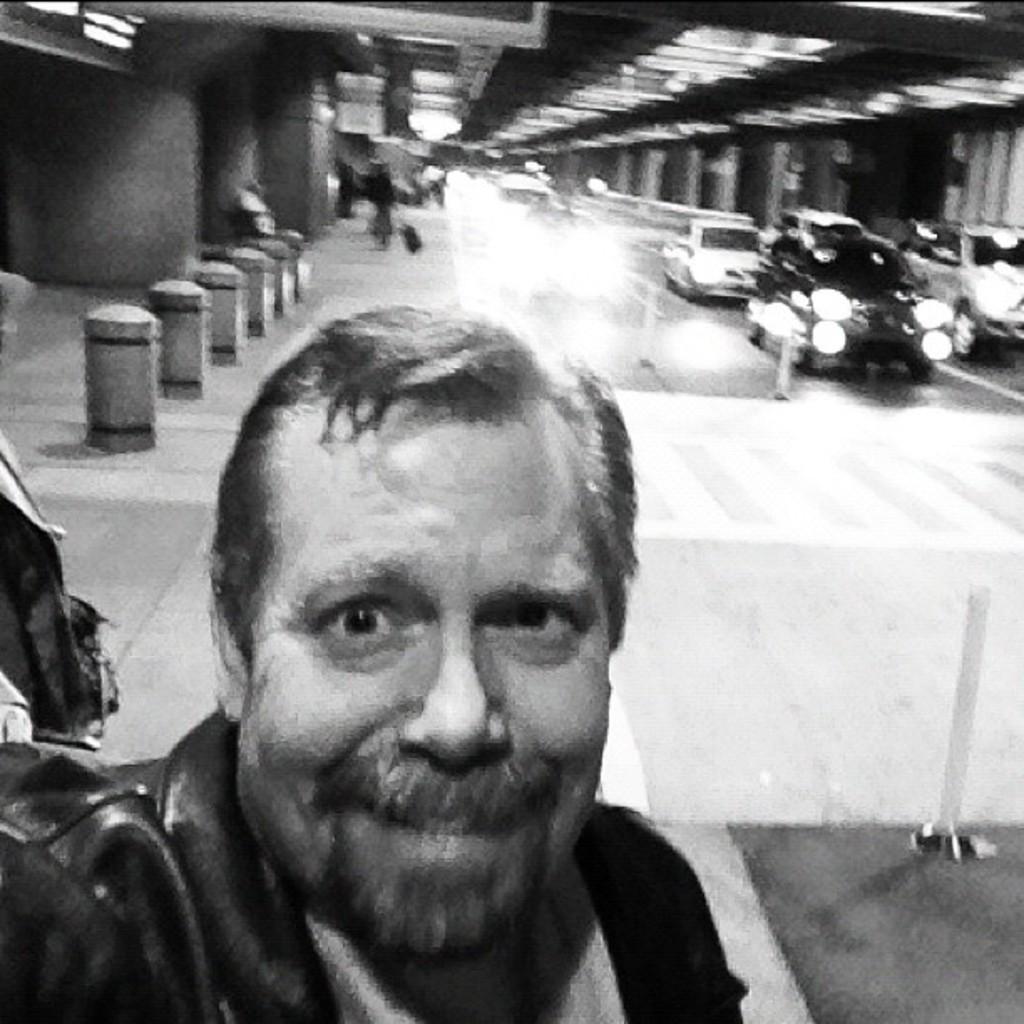Could you give a brief overview of what you see in this image? This is a black and white picture. In this there is a person. In the background there are vehicles, small poles and lights. And it is blurred in the background. 